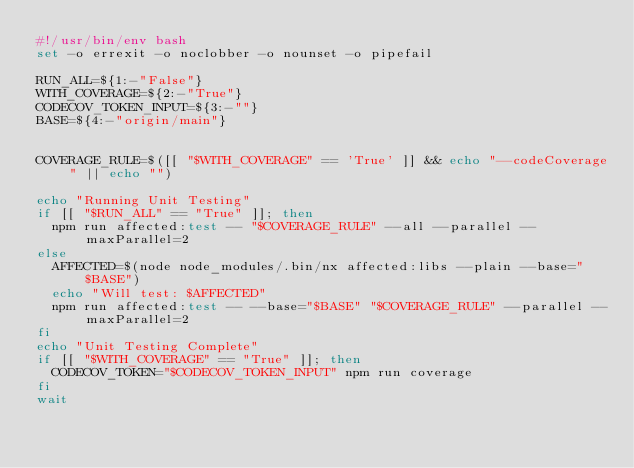<code> <loc_0><loc_0><loc_500><loc_500><_Bash_>#!/usr/bin/env bash
set -o errexit -o noclobber -o nounset -o pipefail

RUN_ALL=${1:-"False"}
WITH_COVERAGE=${2:-"True"}
CODECOV_TOKEN_INPUT=${3:-""}
BASE=${4:-"origin/main"}


COVERAGE_RULE=$([[ "$WITH_COVERAGE" == 'True' ]] && echo "--codeCoverage" || echo "")

echo "Running Unit Testing"
if [[ "$RUN_ALL" == "True" ]]; then
  npm run affected:test -- "$COVERAGE_RULE" --all --parallel --maxParallel=2
else
  AFFECTED=$(node node_modules/.bin/nx affected:libs --plain --base="$BASE")
  echo "Will test: $AFFECTED"
  npm run affected:test -- --base="$BASE" "$COVERAGE_RULE" --parallel --maxParallel=2
fi
echo "Unit Testing Complete"
if [[ "$WITH_COVERAGE" == "True" ]]; then
  CODECOV_TOKEN="$CODECOV_TOKEN_INPUT" npm run coverage
fi
wait
</code> 